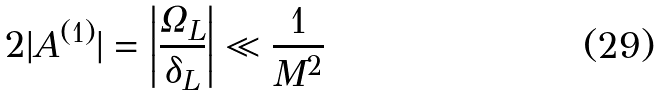Convert formula to latex. <formula><loc_0><loc_0><loc_500><loc_500>2 | A ^ { ( 1 ) } | = \left | \frac { \Omega _ { L } } { \delta _ { L } } \right | \ll \frac { 1 } { M ^ { 2 } }</formula> 